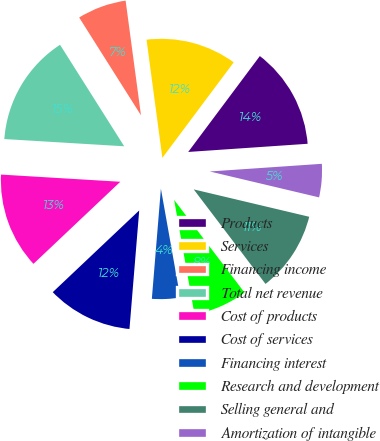<chart> <loc_0><loc_0><loc_500><loc_500><pie_chart><fcel>Products<fcel>Services<fcel>Financing income<fcel>Total net revenue<fcel>Cost of products<fcel>Cost of services<fcel>Financing interest<fcel>Research and development<fcel>Selling general and<fcel>Amortization of intangible<nl><fcel>13.7%<fcel>12.33%<fcel>6.85%<fcel>15.07%<fcel>13.01%<fcel>11.64%<fcel>4.11%<fcel>7.53%<fcel>10.96%<fcel>4.79%<nl></chart> 